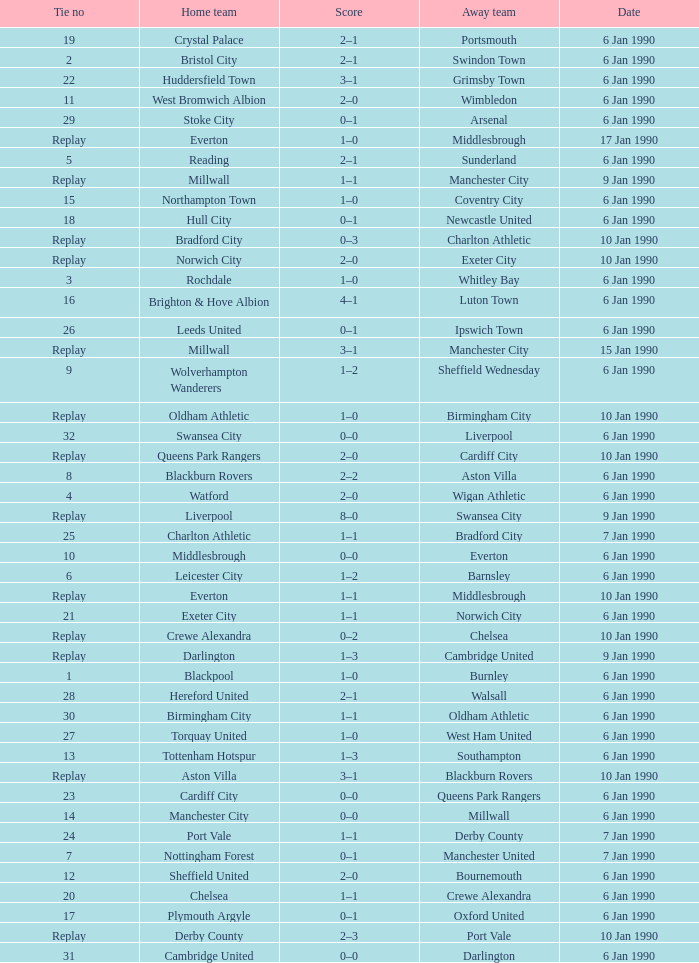Could you parse the entire table as a dict? {'header': ['Tie no', 'Home team', 'Score', 'Away team', 'Date'], 'rows': [['19', 'Crystal Palace', '2–1', 'Portsmouth', '6 Jan 1990'], ['2', 'Bristol City', '2–1', 'Swindon Town', '6 Jan 1990'], ['22', 'Huddersfield Town', '3–1', 'Grimsby Town', '6 Jan 1990'], ['11', 'West Bromwich Albion', '2–0', 'Wimbledon', '6 Jan 1990'], ['29', 'Stoke City', '0–1', 'Arsenal', '6 Jan 1990'], ['Replay', 'Everton', '1–0', 'Middlesbrough', '17 Jan 1990'], ['5', 'Reading', '2–1', 'Sunderland', '6 Jan 1990'], ['Replay', 'Millwall', '1–1', 'Manchester City', '9 Jan 1990'], ['15', 'Northampton Town', '1–0', 'Coventry City', '6 Jan 1990'], ['18', 'Hull City', '0–1', 'Newcastle United', '6 Jan 1990'], ['Replay', 'Bradford City', '0–3', 'Charlton Athletic', '10 Jan 1990'], ['Replay', 'Norwich City', '2–0', 'Exeter City', '10 Jan 1990'], ['3', 'Rochdale', '1–0', 'Whitley Bay', '6 Jan 1990'], ['16', 'Brighton & Hove Albion', '4–1', 'Luton Town', '6 Jan 1990'], ['26', 'Leeds United', '0–1', 'Ipswich Town', '6 Jan 1990'], ['Replay', 'Millwall', '3–1', 'Manchester City', '15 Jan 1990'], ['9', 'Wolverhampton Wanderers', '1–2', 'Sheffield Wednesday', '6 Jan 1990'], ['Replay', 'Oldham Athletic', '1–0', 'Birmingham City', '10 Jan 1990'], ['32', 'Swansea City', '0–0', 'Liverpool', '6 Jan 1990'], ['Replay', 'Queens Park Rangers', '2–0', 'Cardiff City', '10 Jan 1990'], ['8', 'Blackburn Rovers', '2–2', 'Aston Villa', '6 Jan 1990'], ['4', 'Watford', '2–0', 'Wigan Athletic', '6 Jan 1990'], ['Replay', 'Liverpool', '8–0', 'Swansea City', '9 Jan 1990'], ['25', 'Charlton Athletic', '1–1', 'Bradford City', '7 Jan 1990'], ['10', 'Middlesbrough', '0–0', 'Everton', '6 Jan 1990'], ['6', 'Leicester City', '1–2', 'Barnsley', '6 Jan 1990'], ['Replay', 'Everton', '1–1', 'Middlesbrough', '10 Jan 1990'], ['21', 'Exeter City', '1–1', 'Norwich City', '6 Jan 1990'], ['Replay', 'Crewe Alexandra', '0–2', 'Chelsea', '10 Jan 1990'], ['Replay', 'Darlington', '1–3', 'Cambridge United', '9 Jan 1990'], ['1', 'Blackpool', '1–0', 'Burnley', '6 Jan 1990'], ['28', 'Hereford United', '2–1', 'Walsall', '6 Jan 1990'], ['30', 'Birmingham City', '1–1', 'Oldham Athletic', '6 Jan 1990'], ['27', 'Torquay United', '1–0', 'West Ham United', '6 Jan 1990'], ['13', 'Tottenham Hotspur', '1–3', 'Southampton', '6 Jan 1990'], ['Replay', 'Aston Villa', '3–1', 'Blackburn Rovers', '10 Jan 1990'], ['23', 'Cardiff City', '0–0', 'Queens Park Rangers', '6 Jan 1990'], ['14', 'Manchester City', '0–0', 'Millwall', '6 Jan 1990'], ['24', 'Port Vale', '1–1', 'Derby County', '7 Jan 1990'], ['7', 'Nottingham Forest', '0–1', 'Manchester United', '7 Jan 1990'], ['12', 'Sheffield United', '2–0', 'Bournemouth', '6 Jan 1990'], ['20', 'Chelsea', '1–1', 'Crewe Alexandra', '6 Jan 1990'], ['17', 'Plymouth Argyle', '0–1', 'Oxford United', '6 Jan 1990'], ['Replay', 'Derby County', '2–3', 'Port Vale', '10 Jan 1990'], ['31', 'Cambridge United', '0–0', 'Darlington', '6 Jan 1990']]} What is the score of the game against away team exeter city on 10 jan 1990? 2–0. 